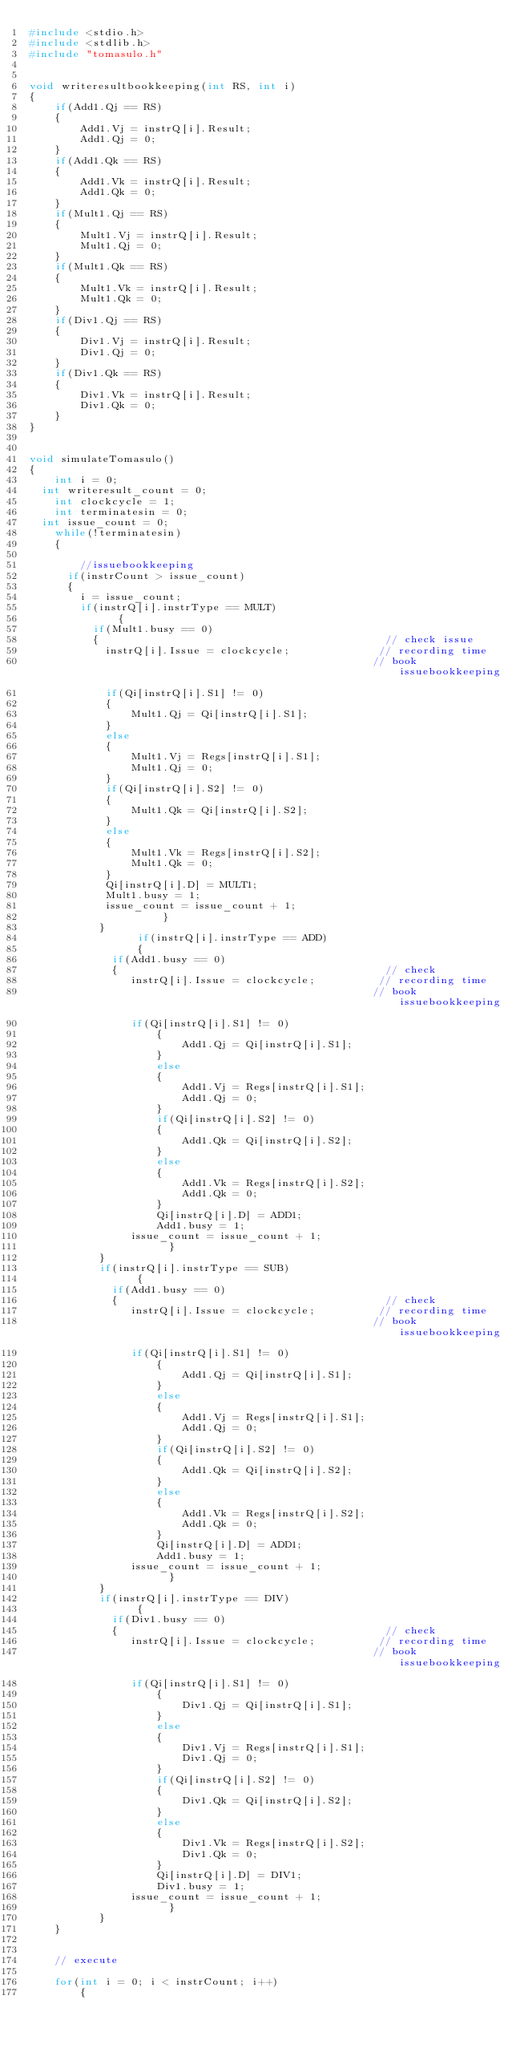Convert code to text. <code><loc_0><loc_0><loc_500><loc_500><_C_>#include <stdio.h>
#include <stdlib.h>
#include "tomasulo.h"


void writeresultbookkeeping(int RS, int i)
{
	if(Add1.Qj == RS)
	{
		Add1.Vj = instrQ[i].Result;
		Add1.Qj = 0;
	}
	if(Add1.Qk == RS)
	{
		Add1.Vk = instrQ[i].Result;
		Add1.Qk = 0;
	}
	if(Mult1.Qj == RS)
	{
		Mult1.Vj = instrQ[i].Result;
		Mult1.Qj = 0;
	}
	if(Mult1.Qk == RS)
	{
		Mult1.Vk = instrQ[i].Result;
		Mult1.Qk = 0;
	}
	if(Div1.Qj == RS)
	{
		Div1.Vj = instrQ[i].Result;
		Div1.Qj = 0;
	}
	if(Div1.Qk == RS)
	{
		Div1.Vk = instrQ[i].Result;
		Div1.Qk = 0;
	}
}


void simulateTomasulo()
{
	int i = 0;
  int writeresult_count = 0;
	int clockcycle = 1;
	int terminatesin = 0;
  int issue_count = 0;
	while(!terminatesin)
	{

		//issuebookkeeping
      if(instrCount > issue_count)
      {
        i = issue_count;
        if(instrQ[i].instrType == MULT)
			  {
          if(Mult1.busy == 0)
          {                                             // check issue
            instrQ[i].Issue = clockcycle;              // recording time
                                                      // book issuebookkeeping
            if(Qi[instrQ[i].S1] != 0)
            {
            	Mult1.Qj = Qi[instrQ[i].S1];
            }
            else
            {
            	Mult1.Vj = Regs[instrQ[i].S1];
            	Mult1.Qj = 0;
            }
            if(Qi[instrQ[i].S2] != 0)
            {
            	Mult1.Qk = Qi[instrQ[i].S2];
            }
            else
            {
            	Mult1.Vk = Regs[instrQ[i].S2];
            	Mult1.Qk = 0;
            }
            Qi[instrQ[i].D] = MULT1;
            Mult1.busy = 1;
            issue_count = issue_count + 1;
				     }
           }
			     if(instrQ[i].instrType == ADD)
			     {
             if(Add1.busy == 0)
             {                                          // check
                instrQ[i].Issue = clockcycle;          // recording time
                                                      // book issuebookkeeping
                if(Qi[instrQ[i].S1] != 0)
          			{
          				Add1.Qj = Qi[instrQ[i].S1];
          			}
          			else
          			{
          				Add1.Vj = Regs[instrQ[i].S1];
          				Add1.Qj = 0;
          			}
          			if(Qi[instrQ[i].S2] != 0)
          			{
          				Add1.Qk = Qi[instrQ[i].S2];
          			}
          			else
          			{
          				Add1.Vk = Regs[instrQ[i].S2];
          				Add1.Qk = 0;
          			}
          			Qi[instrQ[i].D] = ADD1;
          			Add1.busy = 1;
                issue_count = issue_count + 1;
				      }
           }
           if(instrQ[i].instrType == SUB)
			     {
             if(Add1.busy == 0)
             {                                          // check
                instrQ[i].Issue = clockcycle;          // recording time
                                                      // book issuebookkeeping
                if(Qi[instrQ[i].S1] != 0)
          			{
          				Add1.Qj = Qi[instrQ[i].S1];
          			}
          			else
          			{
          				Add1.Vj = Regs[instrQ[i].S1];
          				Add1.Qj = 0;
          			}
          			if(Qi[instrQ[i].S2] != 0)
          			{
          				Add1.Qk = Qi[instrQ[i].S2];
          			}
          			else
          			{
          				Add1.Vk = Regs[instrQ[i].S2];
          				Add1.Qk = 0;
          			}
          			Qi[instrQ[i].D] = ADD1;
          			Add1.busy = 1;
                issue_count = issue_count + 1;
				      }
           }
           if(instrQ[i].instrType == DIV)
			     {
             if(Div1.busy == 0)
             {                                          // check
                instrQ[i].Issue = clockcycle;          // recording time
                                                      // book issuebookkeeping
                if(Qi[instrQ[i].S1] != 0)
          			{
          				Div1.Qj = Qi[instrQ[i].S1];
          			}
          			else
          			{
          				Div1.Vj = Regs[instrQ[i].S1];
          				Div1.Qj = 0;
          			}
          			if(Qi[instrQ[i].S2] != 0)
          			{
          				Div1.Qk = Qi[instrQ[i].S2];
          			}
          			else
          			{
          				Div1.Vk = Regs[instrQ[i].S2];
          				Div1.Qk = 0;
          			}
          			Qi[instrQ[i].D] = DIV1;
          			Div1.busy = 1;
                issue_count = issue_count + 1;
				      }
           }
    }


    // execute

    for(int i = 0; i < instrCount; i++)
		{</code> 